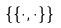Convert formula to latex. <formula><loc_0><loc_0><loc_500><loc_500>\{ \{ \cdot , \cdot \} \}</formula> 